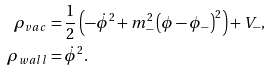Convert formula to latex. <formula><loc_0><loc_0><loc_500><loc_500>\rho _ { v a c } & = \frac { 1 } { 2 } \left ( { - \dot { \phi } ^ { 2 } + m _ { - } ^ { 2 } \left ( { \phi - \phi _ { - } } \right ) ^ { 2 } } \right ) + V _ { - } , \\ \rho _ { w a l l } & = \dot { \phi } ^ { 2 } .</formula> 